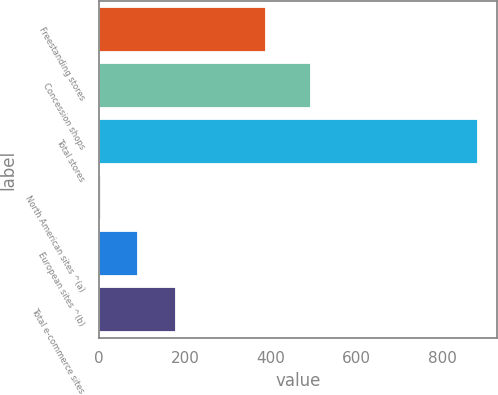Convert chart. <chart><loc_0><loc_0><loc_500><loc_500><bar_chart><fcel>Freestanding stores<fcel>Concession shops<fcel>Total stores<fcel>North American sites ^(a)<fcel>European sites ^(b)<fcel>Total e-commerce sites<nl><fcel>388<fcel>494<fcel>882<fcel>3<fcel>90.9<fcel>178.8<nl></chart> 